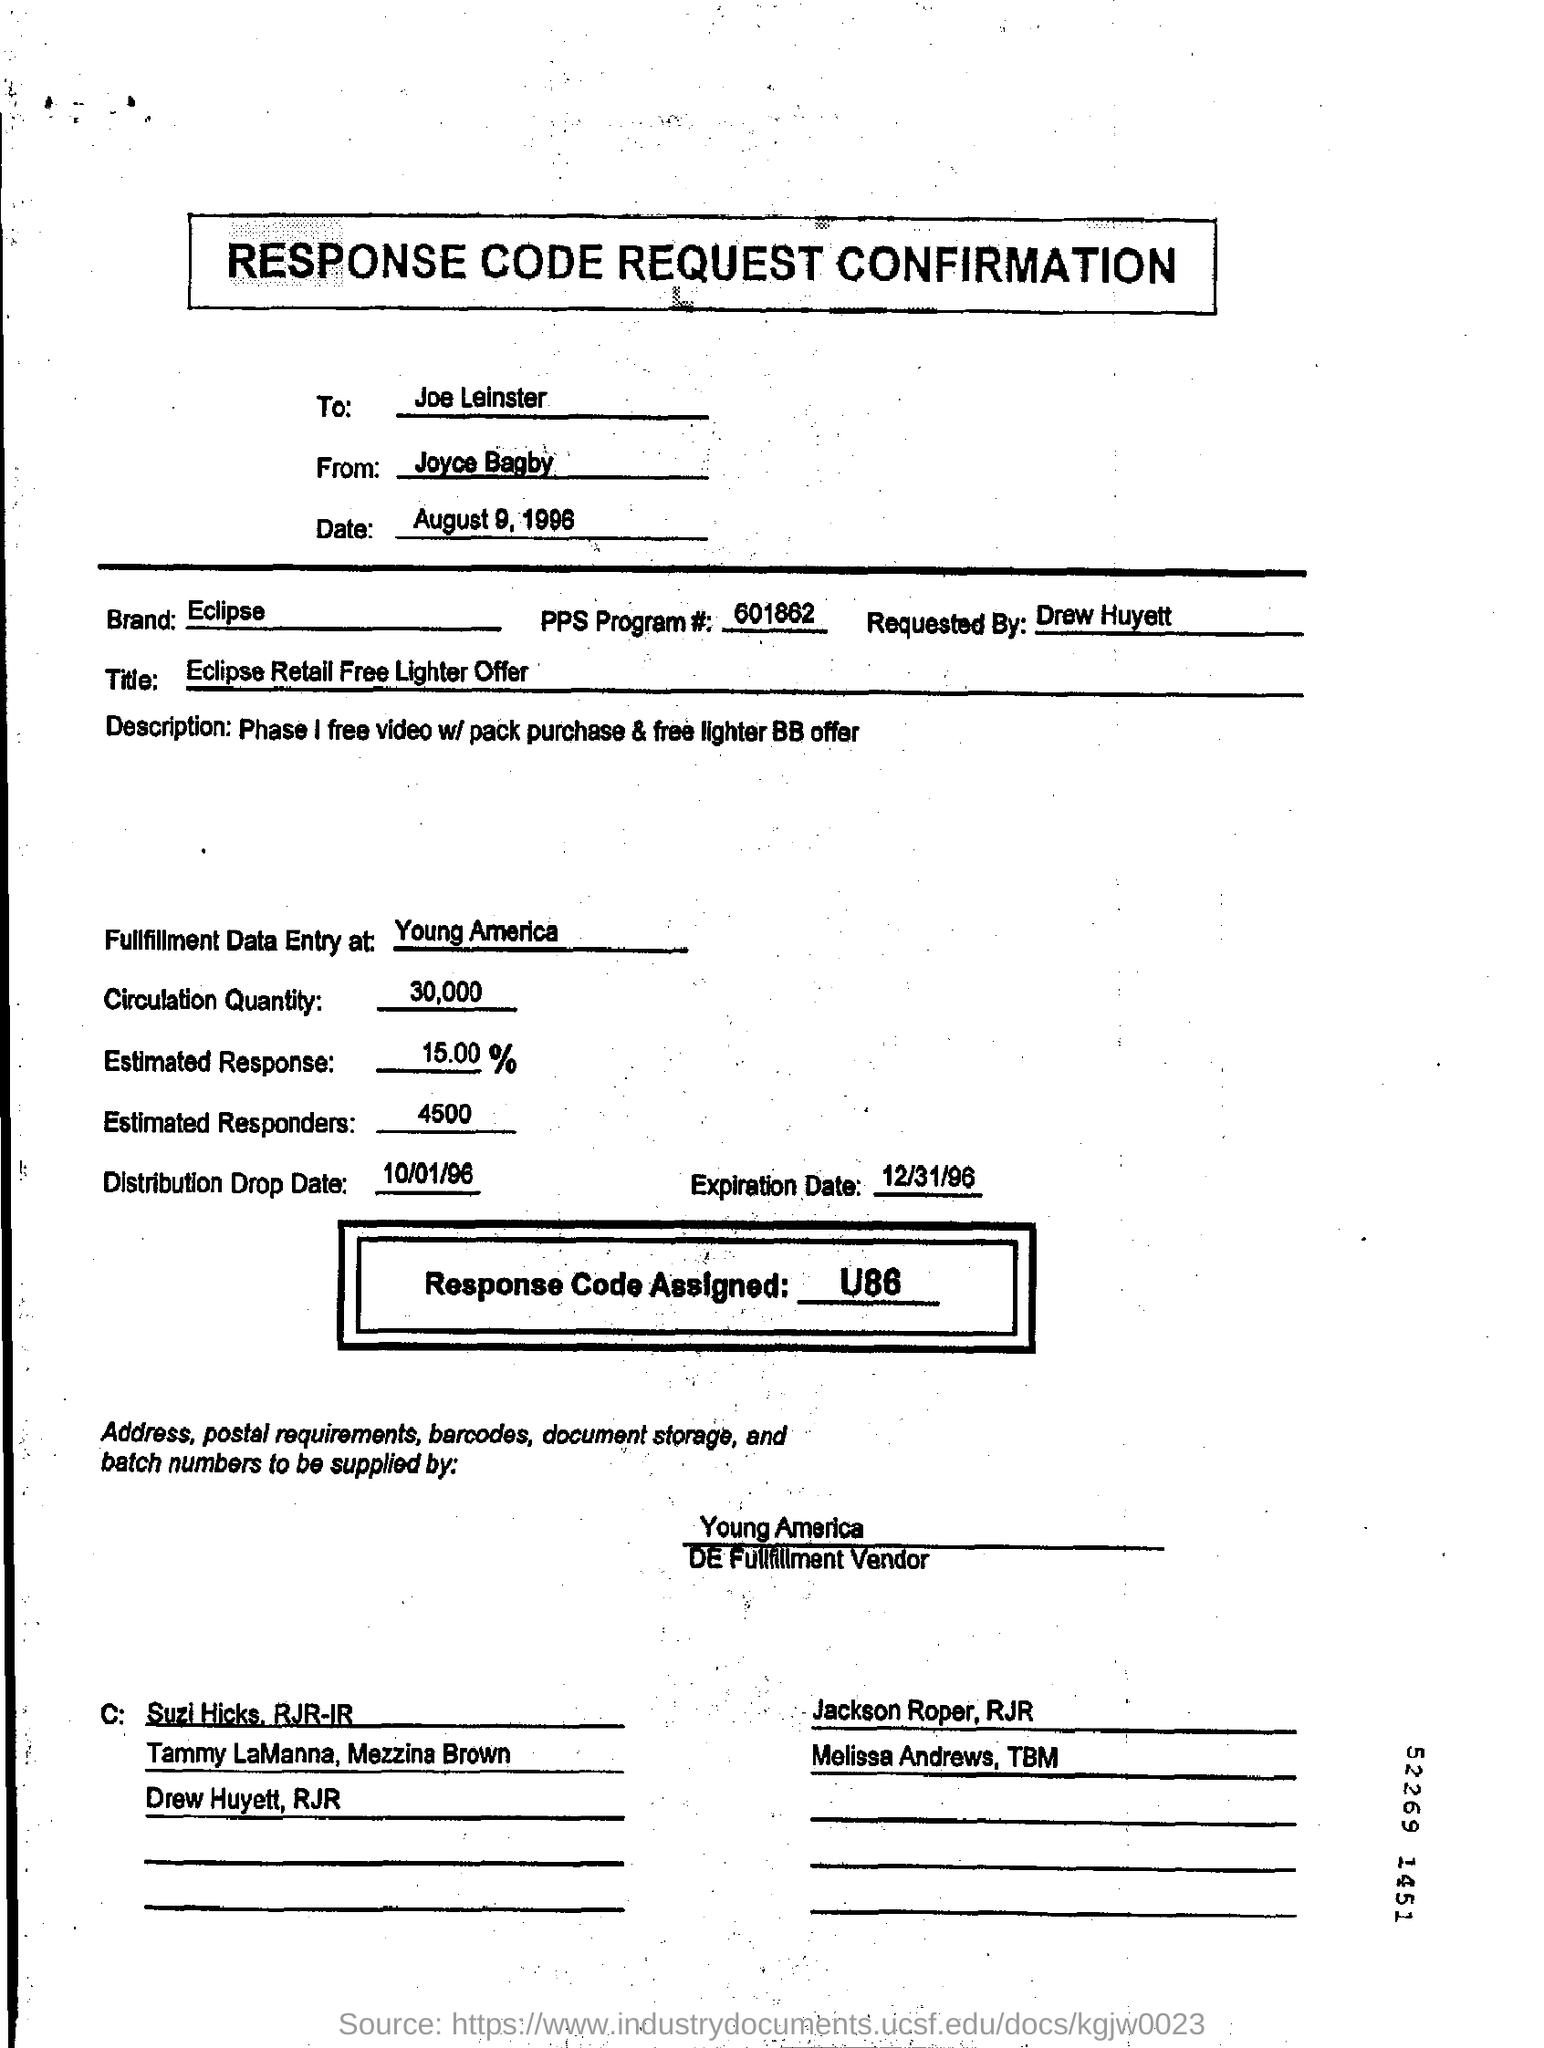Who is it addressed to?
Make the answer very short. Joe Leinster. Who is it From?
Make the answer very short. Joyce Bagby. What is the Date?
Your answer should be compact. August 9, 1996. What is the Brand?
Offer a terse response. Eclipse. What is the PPs Program #?
Give a very brief answer. 601862. Who is it requested by?
Offer a very short reply. Drew Huyett. Which brand is mentioned in the form?
Give a very brief answer. Eclipse. What is the response code assigned?
Make the answer very short. U86. Where is the fullfillment data entry at?
Offer a terse response. Young America. What is the Circulation Qty?
Offer a terse response. 30,000. 